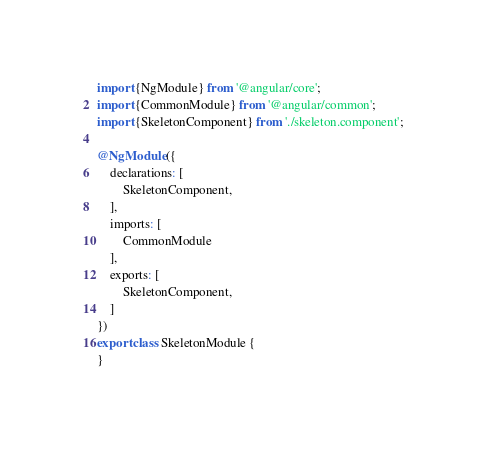Convert code to text. <code><loc_0><loc_0><loc_500><loc_500><_TypeScript_>import {NgModule} from '@angular/core';
import {CommonModule} from '@angular/common';
import {SkeletonComponent} from './skeleton.component';

@NgModule({
    declarations: [
        SkeletonComponent,
    ],
    imports: [
        CommonModule
    ],
    exports: [
        SkeletonComponent,
    ]
})
export class SkeletonModule {
}
</code> 